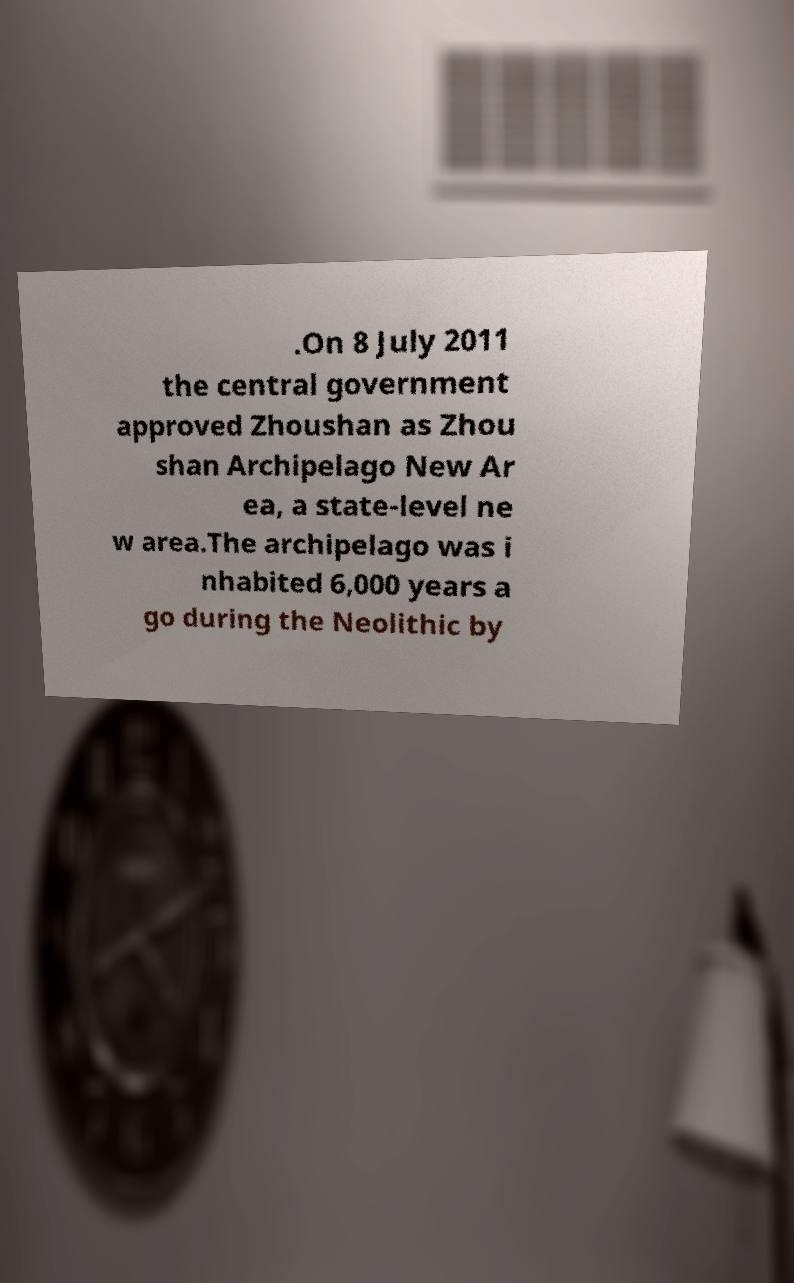Can you read and provide the text displayed in the image?This photo seems to have some interesting text. Can you extract and type it out for me? .On 8 July 2011 the central government approved Zhoushan as Zhou shan Archipelago New Ar ea, a state-level ne w area.The archipelago was i nhabited 6,000 years a go during the Neolithic by 